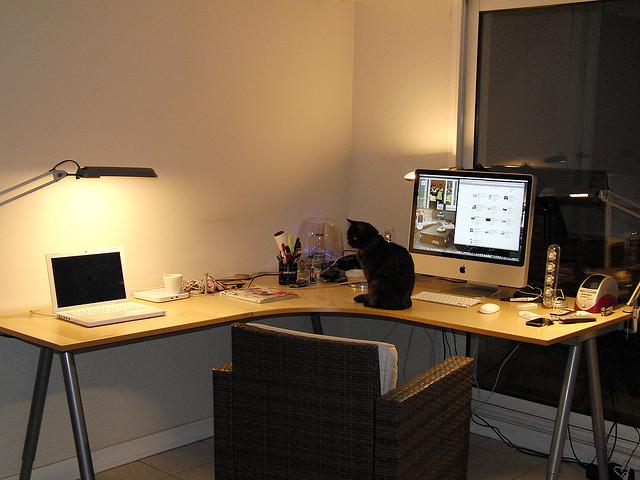Is the lamp on?
Answer briefly. Yes. How many computers are there?
Give a very brief answer. 2. What type of animal is on top of the desk?
Keep it brief. Cat. 